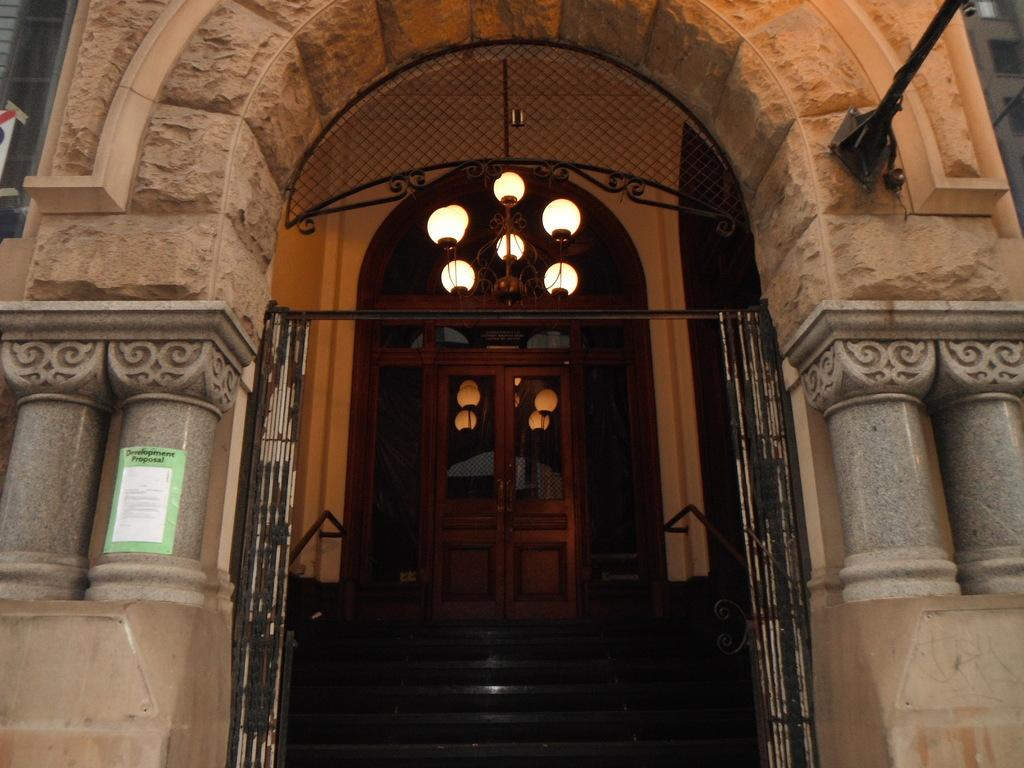What type of structure is shown in the image? The image depicts a building. What architectural feature can be seen in the building? There is an arch in the building. Are there any interior features visible in the image? Yes, there are stairs, a door, a chandelier, and a poster attached to a pillar in the building. What type of haircut does the writer have in the image? There is no writer present in the image, and therefore no haircut can be observed. Can you tell me how many fingers the chandelier has in the image? The chandelier is an inanimate object and does not have fingers. 